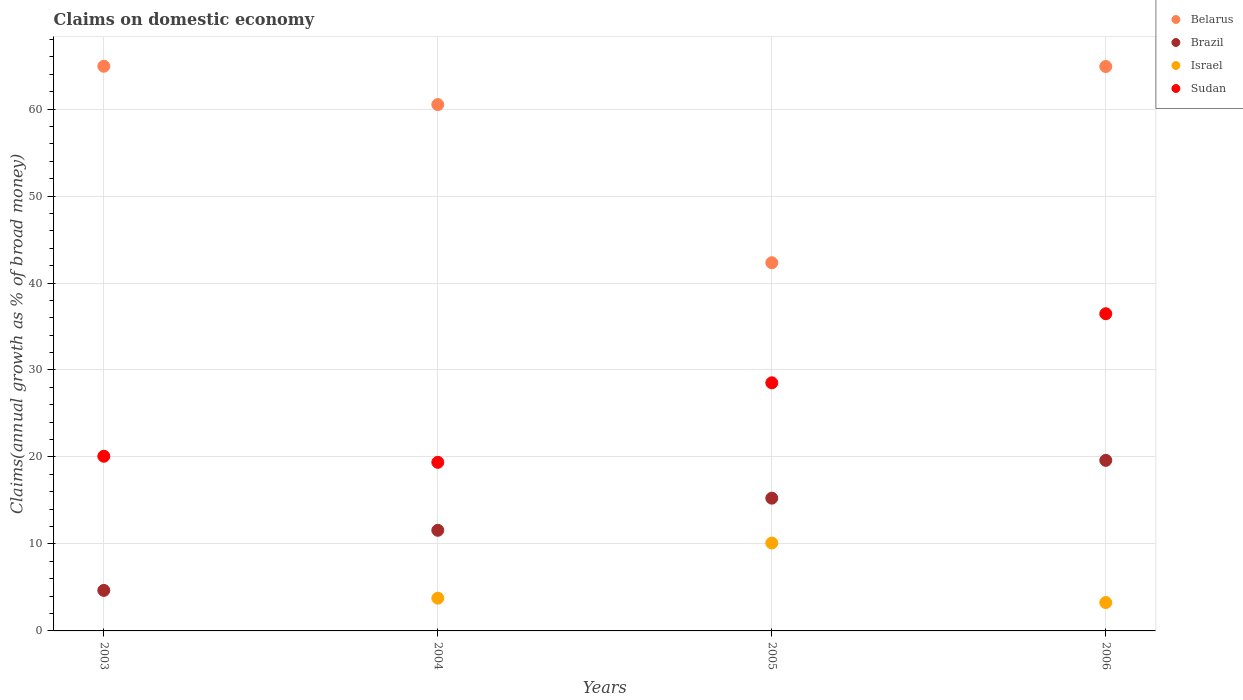What is the percentage of broad money claimed on domestic economy in Brazil in 2005?
Provide a succinct answer. 15.26. Across all years, what is the maximum percentage of broad money claimed on domestic economy in Belarus?
Provide a short and direct response. 64.92. In which year was the percentage of broad money claimed on domestic economy in Belarus maximum?
Your response must be concise. 2003. What is the total percentage of broad money claimed on domestic economy in Brazil in the graph?
Ensure brevity in your answer.  51.1. What is the difference between the percentage of broad money claimed on domestic economy in Brazil in 2003 and that in 2006?
Your answer should be very brief. -14.95. What is the difference between the percentage of broad money claimed on domestic economy in Brazil in 2004 and the percentage of broad money claimed on domestic economy in Israel in 2003?
Keep it short and to the point. 11.57. What is the average percentage of broad money claimed on domestic economy in Sudan per year?
Offer a terse response. 26.11. In the year 2005, what is the difference between the percentage of broad money claimed on domestic economy in Brazil and percentage of broad money claimed on domestic economy in Belarus?
Your response must be concise. -27.07. In how many years, is the percentage of broad money claimed on domestic economy in Belarus greater than 62 %?
Offer a terse response. 2. What is the ratio of the percentage of broad money claimed on domestic economy in Sudan in 2004 to that in 2005?
Your response must be concise. 0.68. Is the difference between the percentage of broad money claimed on domestic economy in Brazil in 2005 and 2006 greater than the difference between the percentage of broad money claimed on domestic economy in Belarus in 2005 and 2006?
Your answer should be compact. Yes. What is the difference between the highest and the second highest percentage of broad money claimed on domestic economy in Israel?
Your response must be concise. 6.34. What is the difference between the highest and the lowest percentage of broad money claimed on domestic economy in Brazil?
Provide a short and direct response. 14.95. In how many years, is the percentage of broad money claimed on domestic economy in Belarus greater than the average percentage of broad money claimed on domestic economy in Belarus taken over all years?
Your answer should be compact. 3. Is the sum of the percentage of broad money claimed on domestic economy in Brazil in 2005 and 2006 greater than the maximum percentage of broad money claimed on domestic economy in Israel across all years?
Provide a short and direct response. Yes. Is it the case that in every year, the sum of the percentage of broad money claimed on domestic economy in Brazil and percentage of broad money claimed on domestic economy in Israel  is greater than the percentage of broad money claimed on domestic economy in Sudan?
Make the answer very short. No. Does the percentage of broad money claimed on domestic economy in Sudan monotonically increase over the years?
Provide a succinct answer. No. Is the percentage of broad money claimed on domestic economy in Israel strictly greater than the percentage of broad money claimed on domestic economy in Belarus over the years?
Make the answer very short. No. Does the graph contain any zero values?
Provide a succinct answer. Yes. Where does the legend appear in the graph?
Your answer should be compact. Top right. How are the legend labels stacked?
Provide a succinct answer. Vertical. What is the title of the graph?
Offer a terse response. Claims on domestic economy. What is the label or title of the X-axis?
Make the answer very short. Years. What is the label or title of the Y-axis?
Your answer should be very brief. Claims(annual growth as % of broad money). What is the Claims(annual growth as % of broad money) in Belarus in 2003?
Keep it short and to the point. 64.92. What is the Claims(annual growth as % of broad money) of Brazil in 2003?
Keep it short and to the point. 4.66. What is the Claims(annual growth as % of broad money) of Sudan in 2003?
Provide a succinct answer. 20.08. What is the Claims(annual growth as % of broad money) in Belarus in 2004?
Offer a very short reply. 60.51. What is the Claims(annual growth as % of broad money) in Brazil in 2004?
Give a very brief answer. 11.57. What is the Claims(annual growth as % of broad money) of Israel in 2004?
Provide a short and direct response. 3.77. What is the Claims(annual growth as % of broad money) of Sudan in 2004?
Make the answer very short. 19.38. What is the Claims(annual growth as % of broad money) in Belarus in 2005?
Provide a short and direct response. 42.33. What is the Claims(annual growth as % of broad money) of Brazil in 2005?
Offer a very short reply. 15.26. What is the Claims(annual growth as % of broad money) of Israel in 2005?
Your response must be concise. 10.1. What is the Claims(annual growth as % of broad money) in Sudan in 2005?
Your answer should be compact. 28.52. What is the Claims(annual growth as % of broad money) in Belarus in 2006?
Offer a very short reply. 64.89. What is the Claims(annual growth as % of broad money) of Brazil in 2006?
Your response must be concise. 19.61. What is the Claims(annual growth as % of broad money) of Israel in 2006?
Your answer should be compact. 3.26. What is the Claims(annual growth as % of broad money) of Sudan in 2006?
Offer a very short reply. 36.47. Across all years, what is the maximum Claims(annual growth as % of broad money) in Belarus?
Your response must be concise. 64.92. Across all years, what is the maximum Claims(annual growth as % of broad money) in Brazil?
Provide a short and direct response. 19.61. Across all years, what is the maximum Claims(annual growth as % of broad money) in Israel?
Offer a very short reply. 10.1. Across all years, what is the maximum Claims(annual growth as % of broad money) in Sudan?
Your response must be concise. 36.47. Across all years, what is the minimum Claims(annual growth as % of broad money) in Belarus?
Offer a very short reply. 42.33. Across all years, what is the minimum Claims(annual growth as % of broad money) in Brazil?
Offer a very short reply. 4.66. Across all years, what is the minimum Claims(annual growth as % of broad money) in Israel?
Make the answer very short. 0. Across all years, what is the minimum Claims(annual growth as % of broad money) of Sudan?
Ensure brevity in your answer.  19.38. What is the total Claims(annual growth as % of broad money) of Belarus in the graph?
Provide a short and direct response. 232.65. What is the total Claims(annual growth as % of broad money) of Brazil in the graph?
Offer a terse response. 51.1. What is the total Claims(annual growth as % of broad money) in Israel in the graph?
Ensure brevity in your answer.  17.13. What is the total Claims(annual growth as % of broad money) of Sudan in the graph?
Your answer should be compact. 104.46. What is the difference between the Claims(annual growth as % of broad money) of Belarus in 2003 and that in 2004?
Ensure brevity in your answer.  4.41. What is the difference between the Claims(annual growth as % of broad money) of Brazil in 2003 and that in 2004?
Offer a very short reply. -6.91. What is the difference between the Claims(annual growth as % of broad money) of Sudan in 2003 and that in 2004?
Your answer should be compact. 0.7. What is the difference between the Claims(annual growth as % of broad money) of Belarus in 2003 and that in 2005?
Ensure brevity in your answer.  22.59. What is the difference between the Claims(annual growth as % of broad money) in Brazil in 2003 and that in 2005?
Your response must be concise. -10.6. What is the difference between the Claims(annual growth as % of broad money) of Sudan in 2003 and that in 2005?
Offer a very short reply. -8.44. What is the difference between the Claims(annual growth as % of broad money) in Belarus in 2003 and that in 2006?
Offer a terse response. 0.03. What is the difference between the Claims(annual growth as % of broad money) in Brazil in 2003 and that in 2006?
Offer a very short reply. -14.95. What is the difference between the Claims(annual growth as % of broad money) in Sudan in 2003 and that in 2006?
Provide a succinct answer. -16.38. What is the difference between the Claims(annual growth as % of broad money) in Belarus in 2004 and that in 2005?
Provide a succinct answer. 18.18. What is the difference between the Claims(annual growth as % of broad money) in Brazil in 2004 and that in 2005?
Provide a short and direct response. -3.69. What is the difference between the Claims(annual growth as % of broad money) in Israel in 2004 and that in 2005?
Ensure brevity in your answer.  -6.34. What is the difference between the Claims(annual growth as % of broad money) of Sudan in 2004 and that in 2005?
Ensure brevity in your answer.  -9.14. What is the difference between the Claims(annual growth as % of broad money) of Belarus in 2004 and that in 2006?
Provide a short and direct response. -4.38. What is the difference between the Claims(annual growth as % of broad money) of Brazil in 2004 and that in 2006?
Offer a very short reply. -8.04. What is the difference between the Claims(annual growth as % of broad money) of Israel in 2004 and that in 2006?
Provide a short and direct response. 0.51. What is the difference between the Claims(annual growth as % of broad money) in Sudan in 2004 and that in 2006?
Provide a succinct answer. -17.08. What is the difference between the Claims(annual growth as % of broad money) of Belarus in 2005 and that in 2006?
Your answer should be compact. -22.56. What is the difference between the Claims(annual growth as % of broad money) in Brazil in 2005 and that in 2006?
Ensure brevity in your answer.  -4.35. What is the difference between the Claims(annual growth as % of broad money) of Israel in 2005 and that in 2006?
Your answer should be very brief. 6.84. What is the difference between the Claims(annual growth as % of broad money) in Sudan in 2005 and that in 2006?
Ensure brevity in your answer.  -7.94. What is the difference between the Claims(annual growth as % of broad money) of Belarus in 2003 and the Claims(annual growth as % of broad money) of Brazil in 2004?
Provide a short and direct response. 53.35. What is the difference between the Claims(annual growth as % of broad money) of Belarus in 2003 and the Claims(annual growth as % of broad money) of Israel in 2004?
Offer a terse response. 61.15. What is the difference between the Claims(annual growth as % of broad money) in Belarus in 2003 and the Claims(annual growth as % of broad money) in Sudan in 2004?
Make the answer very short. 45.54. What is the difference between the Claims(annual growth as % of broad money) in Brazil in 2003 and the Claims(annual growth as % of broad money) in Israel in 2004?
Offer a very short reply. 0.89. What is the difference between the Claims(annual growth as % of broad money) of Brazil in 2003 and the Claims(annual growth as % of broad money) of Sudan in 2004?
Your answer should be compact. -14.72. What is the difference between the Claims(annual growth as % of broad money) of Belarus in 2003 and the Claims(annual growth as % of broad money) of Brazil in 2005?
Your answer should be compact. 49.66. What is the difference between the Claims(annual growth as % of broad money) in Belarus in 2003 and the Claims(annual growth as % of broad money) in Israel in 2005?
Provide a short and direct response. 54.82. What is the difference between the Claims(annual growth as % of broad money) in Belarus in 2003 and the Claims(annual growth as % of broad money) in Sudan in 2005?
Your answer should be compact. 36.4. What is the difference between the Claims(annual growth as % of broad money) of Brazil in 2003 and the Claims(annual growth as % of broad money) of Israel in 2005?
Ensure brevity in your answer.  -5.45. What is the difference between the Claims(annual growth as % of broad money) in Brazil in 2003 and the Claims(annual growth as % of broad money) in Sudan in 2005?
Your answer should be compact. -23.87. What is the difference between the Claims(annual growth as % of broad money) of Belarus in 2003 and the Claims(annual growth as % of broad money) of Brazil in 2006?
Make the answer very short. 45.31. What is the difference between the Claims(annual growth as % of broad money) of Belarus in 2003 and the Claims(annual growth as % of broad money) of Israel in 2006?
Your answer should be very brief. 61.66. What is the difference between the Claims(annual growth as % of broad money) of Belarus in 2003 and the Claims(annual growth as % of broad money) of Sudan in 2006?
Offer a very short reply. 28.45. What is the difference between the Claims(annual growth as % of broad money) of Brazil in 2003 and the Claims(annual growth as % of broad money) of Israel in 2006?
Your answer should be compact. 1.4. What is the difference between the Claims(annual growth as % of broad money) of Brazil in 2003 and the Claims(annual growth as % of broad money) of Sudan in 2006?
Provide a succinct answer. -31.81. What is the difference between the Claims(annual growth as % of broad money) of Belarus in 2004 and the Claims(annual growth as % of broad money) of Brazil in 2005?
Your response must be concise. 45.25. What is the difference between the Claims(annual growth as % of broad money) of Belarus in 2004 and the Claims(annual growth as % of broad money) of Israel in 2005?
Provide a short and direct response. 50.41. What is the difference between the Claims(annual growth as % of broad money) of Belarus in 2004 and the Claims(annual growth as % of broad money) of Sudan in 2005?
Provide a succinct answer. 31.99. What is the difference between the Claims(annual growth as % of broad money) in Brazil in 2004 and the Claims(annual growth as % of broad money) in Israel in 2005?
Your response must be concise. 1.46. What is the difference between the Claims(annual growth as % of broad money) in Brazil in 2004 and the Claims(annual growth as % of broad money) in Sudan in 2005?
Make the answer very short. -16.96. What is the difference between the Claims(annual growth as % of broad money) of Israel in 2004 and the Claims(annual growth as % of broad money) of Sudan in 2005?
Provide a short and direct response. -24.76. What is the difference between the Claims(annual growth as % of broad money) of Belarus in 2004 and the Claims(annual growth as % of broad money) of Brazil in 2006?
Ensure brevity in your answer.  40.9. What is the difference between the Claims(annual growth as % of broad money) of Belarus in 2004 and the Claims(annual growth as % of broad money) of Israel in 2006?
Provide a short and direct response. 57.25. What is the difference between the Claims(annual growth as % of broad money) in Belarus in 2004 and the Claims(annual growth as % of broad money) in Sudan in 2006?
Give a very brief answer. 24.05. What is the difference between the Claims(annual growth as % of broad money) of Brazil in 2004 and the Claims(annual growth as % of broad money) of Israel in 2006?
Offer a terse response. 8.31. What is the difference between the Claims(annual growth as % of broad money) of Brazil in 2004 and the Claims(annual growth as % of broad money) of Sudan in 2006?
Keep it short and to the point. -24.9. What is the difference between the Claims(annual growth as % of broad money) in Israel in 2004 and the Claims(annual growth as % of broad money) in Sudan in 2006?
Provide a short and direct response. -32.7. What is the difference between the Claims(annual growth as % of broad money) of Belarus in 2005 and the Claims(annual growth as % of broad money) of Brazil in 2006?
Make the answer very short. 22.72. What is the difference between the Claims(annual growth as % of broad money) of Belarus in 2005 and the Claims(annual growth as % of broad money) of Israel in 2006?
Give a very brief answer. 39.07. What is the difference between the Claims(annual growth as % of broad money) of Belarus in 2005 and the Claims(annual growth as % of broad money) of Sudan in 2006?
Give a very brief answer. 5.87. What is the difference between the Claims(annual growth as % of broad money) of Brazil in 2005 and the Claims(annual growth as % of broad money) of Israel in 2006?
Provide a succinct answer. 12. What is the difference between the Claims(annual growth as % of broad money) of Brazil in 2005 and the Claims(annual growth as % of broad money) of Sudan in 2006?
Your response must be concise. -21.2. What is the difference between the Claims(annual growth as % of broad money) in Israel in 2005 and the Claims(annual growth as % of broad money) in Sudan in 2006?
Make the answer very short. -26.36. What is the average Claims(annual growth as % of broad money) in Belarus per year?
Keep it short and to the point. 58.16. What is the average Claims(annual growth as % of broad money) in Brazil per year?
Provide a succinct answer. 12.77. What is the average Claims(annual growth as % of broad money) of Israel per year?
Give a very brief answer. 4.28. What is the average Claims(annual growth as % of broad money) in Sudan per year?
Your answer should be compact. 26.11. In the year 2003, what is the difference between the Claims(annual growth as % of broad money) in Belarus and Claims(annual growth as % of broad money) in Brazil?
Provide a succinct answer. 60.26. In the year 2003, what is the difference between the Claims(annual growth as % of broad money) of Belarus and Claims(annual growth as % of broad money) of Sudan?
Give a very brief answer. 44.84. In the year 2003, what is the difference between the Claims(annual growth as % of broad money) in Brazil and Claims(annual growth as % of broad money) in Sudan?
Make the answer very short. -15.42. In the year 2004, what is the difference between the Claims(annual growth as % of broad money) of Belarus and Claims(annual growth as % of broad money) of Brazil?
Keep it short and to the point. 48.94. In the year 2004, what is the difference between the Claims(annual growth as % of broad money) of Belarus and Claims(annual growth as % of broad money) of Israel?
Your answer should be very brief. 56.75. In the year 2004, what is the difference between the Claims(annual growth as % of broad money) of Belarus and Claims(annual growth as % of broad money) of Sudan?
Offer a very short reply. 41.13. In the year 2004, what is the difference between the Claims(annual growth as % of broad money) of Brazil and Claims(annual growth as % of broad money) of Israel?
Offer a very short reply. 7.8. In the year 2004, what is the difference between the Claims(annual growth as % of broad money) in Brazil and Claims(annual growth as % of broad money) in Sudan?
Your response must be concise. -7.81. In the year 2004, what is the difference between the Claims(annual growth as % of broad money) in Israel and Claims(annual growth as % of broad money) in Sudan?
Give a very brief answer. -15.62. In the year 2005, what is the difference between the Claims(annual growth as % of broad money) of Belarus and Claims(annual growth as % of broad money) of Brazil?
Offer a very short reply. 27.07. In the year 2005, what is the difference between the Claims(annual growth as % of broad money) of Belarus and Claims(annual growth as % of broad money) of Israel?
Keep it short and to the point. 32.23. In the year 2005, what is the difference between the Claims(annual growth as % of broad money) of Belarus and Claims(annual growth as % of broad money) of Sudan?
Keep it short and to the point. 13.81. In the year 2005, what is the difference between the Claims(annual growth as % of broad money) of Brazil and Claims(annual growth as % of broad money) of Israel?
Provide a short and direct response. 5.16. In the year 2005, what is the difference between the Claims(annual growth as % of broad money) of Brazil and Claims(annual growth as % of broad money) of Sudan?
Your answer should be compact. -13.26. In the year 2005, what is the difference between the Claims(annual growth as % of broad money) in Israel and Claims(annual growth as % of broad money) in Sudan?
Your response must be concise. -18.42. In the year 2006, what is the difference between the Claims(annual growth as % of broad money) in Belarus and Claims(annual growth as % of broad money) in Brazil?
Offer a very short reply. 45.28. In the year 2006, what is the difference between the Claims(annual growth as % of broad money) in Belarus and Claims(annual growth as % of broad money) in Israel?
Keep it short and to the point. 61.63. In the year 2006, what is the difference between the Claims(annual growth as % of broad money) in Belarus and Claims(annual growth as % of broad money) in Sudan?
Provide a succinct answer. 28.42. In the year 2006, what is the difference between the Claims(annual growth as % of broad money) in Brazil and Claims(annual growth as % of broad money) in Israel?
Ensure brevity in your answer.  16.35. In the year 2006, what is the difference between the Claims(annual growth as % of broad money) of Brazil and Claims(annual growth as % of broad money) of Sudan?
Give a very brief answer. -16.86. In the year 2006, what is the difference between the Claims(annual growth as % of broad money) of Israel and Claims(annual growth as % of broad money) of Sudan?
Offer a terse response. -33.2. What is the ratio of the Claims(annual growth as % of broad money) of Belarus in 2003 to that in 2004?
Offer a terse response. 1.07. What is the ratio of the Claims(annual growth as % of broad money) in Brazil in 2003 to that in 2004?
Provide a short and direct response. 0.4. What is the ratio of the Claims(annual growth as % of broad money) of Sudan in 2003 to that in 2004?
Provide a short and direct response. 1.04. What is the ratio of the Claims(annual growth as % of broad money) of Belarus in 2003 to that in 2005?
Give a very brief answer. 1.53. What is the ratio of the Claims(annual growth as % of broad money) in Brazil in 2003 to that in 2005?
Ensure brevity in your answer.  0.31. What is the ratio of the Claims(annual growth as % of broad money) in Sudan in 2003 to that in 2005?
Provide a succinct answer. 0.7. What is the ratio of the Claims(annual growth as % of broad money) in Brazil in 2003 to that in 2006?
Offer a very short reply. 0.24. What is the ratio of the Claims(annual growth as % of broad money) in Sudan in 2003 to that in 2006?
Offer a very short reply. 0.55. What is the ratio of the Claims(annual growth as % of broad money) in Belarus in 2004 to that in 2005?
Your answer should be compact. 1.43. What is the ratio of the Claims(annual growth as % of broad money) of Brazil in 2004 to that in 2005?
Your answer should be compact. 0.76. What is the ratio of the Claims(annual growth as % of broad money) in Israel in 2004 to that in 2005?
Provide a succinct answer. 0.37. What is the ratio of the Claims(annual growth as % of broad money) in Sudan in 2004 to that in 2005?
Offer a very short reply. 0.68. What is the ratio of the Claims(annual growth as % of broad money) in Belarus in 2004 to that in 2006?
Ensure brevity in your answer.  0.93. What is the ratio of the Claims(annual growth as % of broad money) of Brazil in 2004 to that in 2006?
Ensure brevity in your answer.  0.59. What is the ratio of the Claims(annual growth as % of broad money) of Israel in 2004 to that in 2006?
Your response must be concise. 1.15. What is the ratio of the Claims(annual growth as % of broad money) in Sudan in 2004 to that in 2006?
Provide a succinct answer. 0.53. What is the ratio of the Claims(annual growth as % of broad money) of Belarus in 2005 to that in 2006?
Your response must be concise. 0.65. What is the ratio of the Claims(annual growth as % of broad money) in Brazil in 2005 to that in 2006?
Provide a succinct answer. 0.78. What is the ratio of the Claims(annual growth as % of broad money) of Israel in 2005 to that in 2006?
Give a very brief answer. 3.1. What is the ratio of the Claims(annual growth as % of broad money) in Sudan in 2005 to that in 2006?
Ensure brevity in your answer.  0.78. What is the difference between the highest and the second highest Claims(annual growth as % of broad money) in Belarus?
Provide a succinct answer. 0.03. What is the difference between the highest and the second highest Claims(annual growth as % of broad money) of Brazil?
Provide a short and direct response. 4.35. What is the difference between the highest and the second highest Claims(annual growth as % of broad money) in Israel?
Your response must be concise. 6.34. What is the difference between the highest and the second highest Claims(annual growth as % of broad money) of Sudan?
Keep it short and to the point. 7.94. What is the difference between the highest and the lowest Claims(annual growth as % of broad money) of Belarus?
Make the answer very short. 22.59. What is the difference between the highest and the lowest Claims(annual growth as % of broad money) of Brazil?
Your answer should be compact. 14.95. What is the difference between the highest and the lowest Claims(annual growth as % of broad money) of Israel?
Ensure brevity in your answer.  10.1. What is the difference between the highest and the lowest Claims(annual growth as % of broad money) of Sudan?
Make the answer very short. 17.08. 